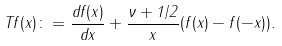Convert formula to latex. <formula><loc_0><loc_0><loc_500><loc_500>T f ( x ) \colon = \frac { d f ( x ) } { d x } + \frac { \nu + 1 / 2 } { x } ( f ( x ) - f ( - x ) ) .</formula> 